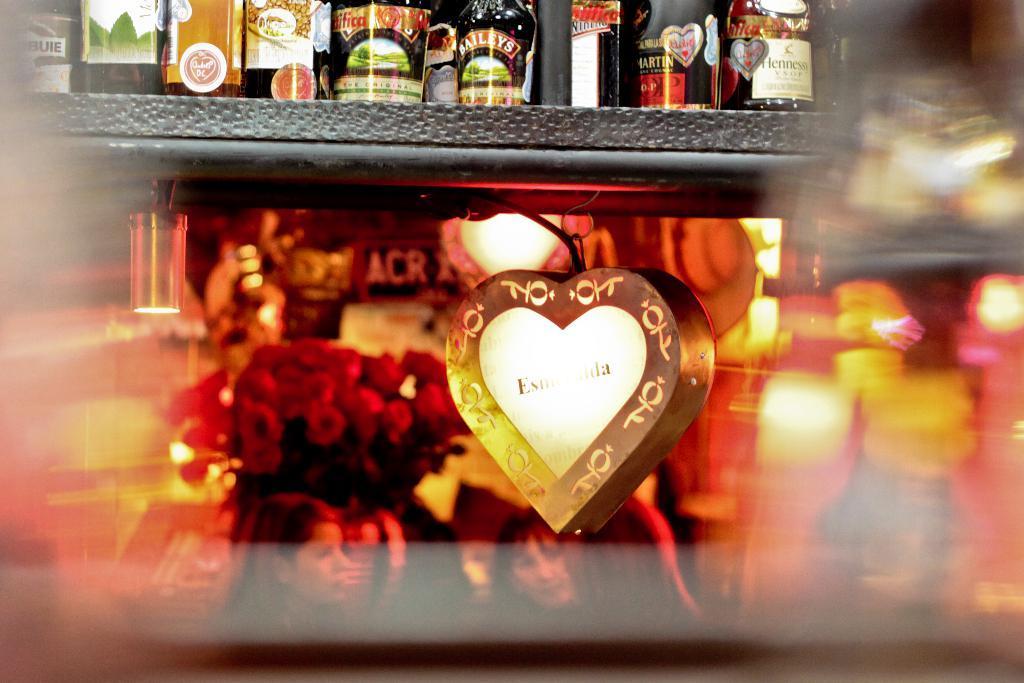How would you summarize this image in a sentence or two? At the bottom of the image there are persons, flower vase and decor. At the top of the image there is a rack and things placed on it. 